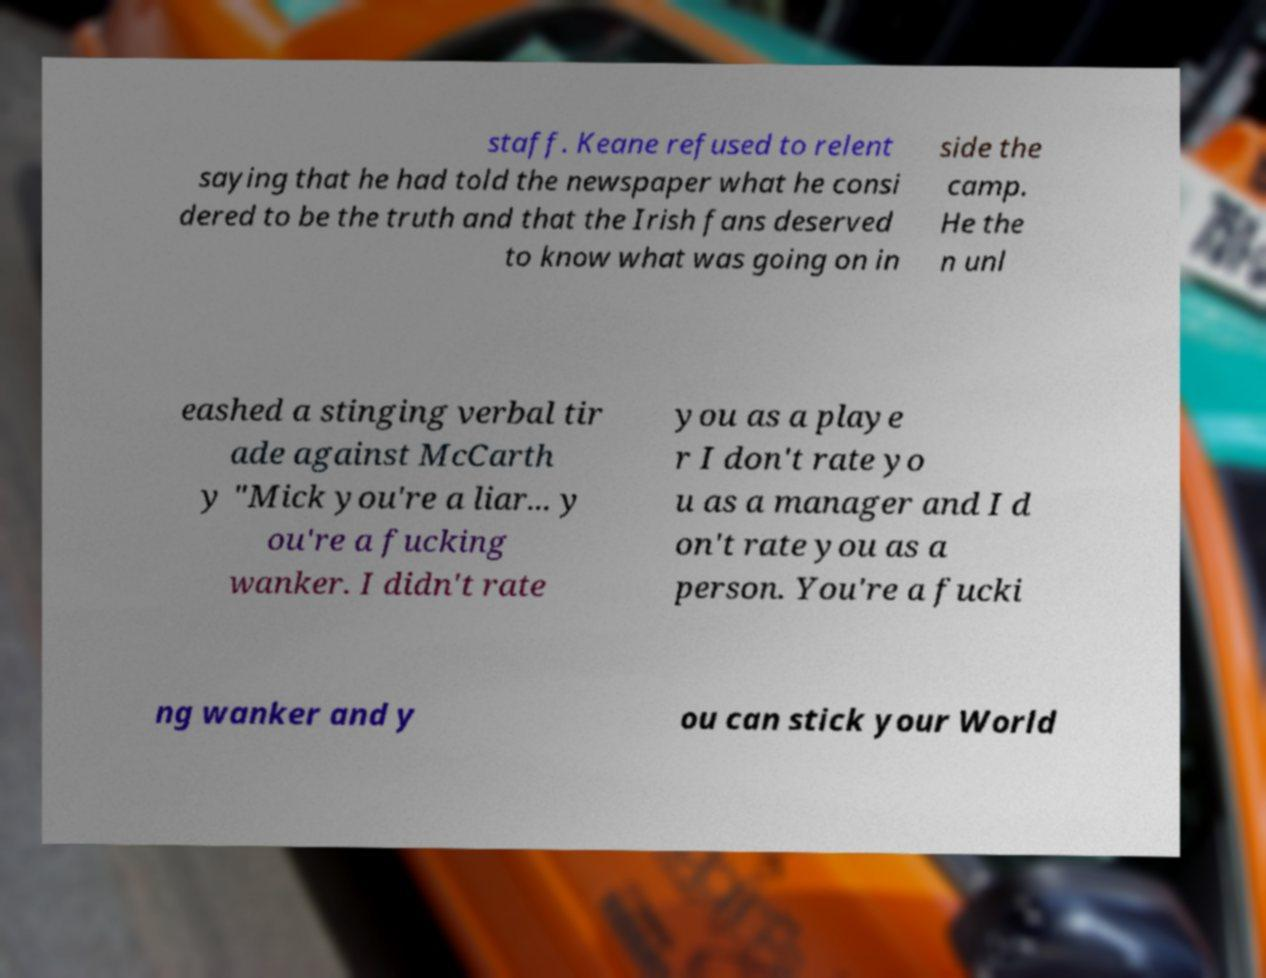Can you read and provide the text displayed in the image?This photo seems to have some interesting text. Can you extract and type it out for me? staff. Keane refused to relent saying that he had told the newspaper what he consi dered to be the truth and that the Irish fans deserved to know what was going on in side the camp. He the n unl eashed a stinging verbal tir ade against McCarth y "Mick you're a liar... y ou're a fucking wanker. I didn't rate you as a playe r I don't rate yo u as a manager and I d on't rate you as a person. You're a fucki ng wanker and y ou can stick your World 